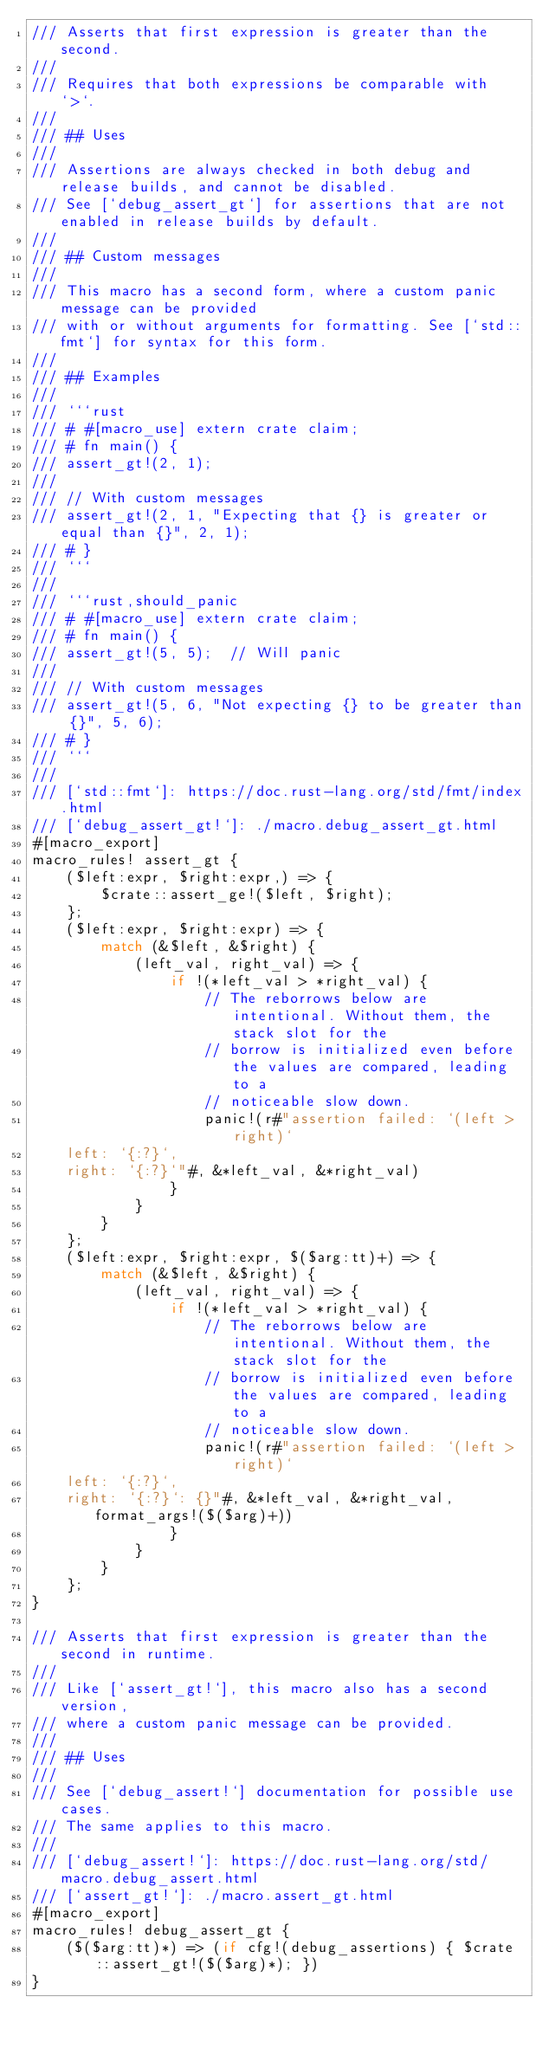Convert code to text. <code><loc_0><loc_0><loc_500><loc_500><_Rust_>/// Asserts that first expression is greater than the second.
///
/// Requires that both expressions be comparable with `>`.
///
/// ## Uses
///
/// Assertions are always checked in both debug and release builds, and cannot be disabled.
/// See [`debug_assert_gt`] for assertions that are not enabled in release builds by default.
///
/// ## Custom messages
///
/// This macro has a second form, where a custom panic message can be provided
/// with or without arguments for formatting. See [`std::fmt`] for syntax for this form.
///
/// ## Examples
///
/// ```rust
/// # #[macro_use] extern crate claim;
/// # fn main() {
/// assert_gt!(2, 1);
///
/// // With custom messages
/// assert_gt!(2, 1, "Expecting that {} is greater or equal than {}", 2, 1);
/// # }
/// ```
///
/// ```rust,should_panic
/// # #[macro_use] extern crate claim;
/// # fn main() {
/// assert_gt!(5, 5);  // Will panic
///
/// // With custom messages
/// assert_gt!(5, 6, "Not expecting {} to be greater than {}", 5, 6);
/// # }
/// ```
///
/// [`std::fmt`]: https://doc.rust-lang.org/std/fmt/index.html
/// [`debug_assert_gt!`]: ./macro.debug_assert_gt.html
#[macro_export]
macro_rules! assert_gt {
    ($left:expr, $right:expr,) => {
        $crate::assert_ge!($left, $right);
    };
    ($left:expr, $right:expr) => {
        match (&$left, &$right) {
            (left_val, right_val) => {
                if !(*left_val > *right_val) {
                    // The reborrows below are intentional. Without them, the stack slot for the
                    // borrow is initialized even before the values are compared, leading to a
                    // noticeable slow down.
                    panic!(r#"assertion failed: `(left > right)`
    left: `{:?}`,
    right: `{:?}`"#, &*left_val, &*right_val)
                }
            }
        }
    };
    ($left:expr, $right:expr, $($arg:tt)+) => {
        match (&$left, &$right) {
            (left_val, right_val) => {
                if !(*left_val > *right_val) {
                    // The reborrows below are intentional. Without them, the stack slot for the
                    // borrow is initialized even before the values are compared, leading to a
                    // noticeable slow down.
                    panic!(r#"assertion failed: `(left > right)`
    left: `{:?}`,
    right: `{:?}`: {}"#, &*left_val, &*right_val, format_args!($($arg)+))
                }
            }
        }
    };
}

/// Asserts that first expression is greater than the second in runtime.
///
/// Like [`assert_gt!`], this macro also has a second version,
/// where a custom panic message can be provided.
///
/// ## Uses
///
/// See [`debug_assert!`] documentation for possible use cases.
/// The same applies to this macro.
///
/// [`debug_assert!`]: https://doc.rust-lang.org/std/macro.debug_assert.html
/// [`assert_gt!`]: ./macro.assert_gt.html
#[macro_export]
macro_rules! debug_assert_gt {
    ($($arg:tt)*) => (if cfg!(debug_assertions) { $crate::assert_gt!($($arg)*); })
}
</code> 